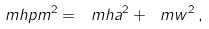Convert formula to latex. <formula><loc_0><loc_0><loc_500><loc_500>\ m h p m ^ { 2 } = \ m h a ^ { 2 } + \ m w ^ { 2 } \, ,</formula> 